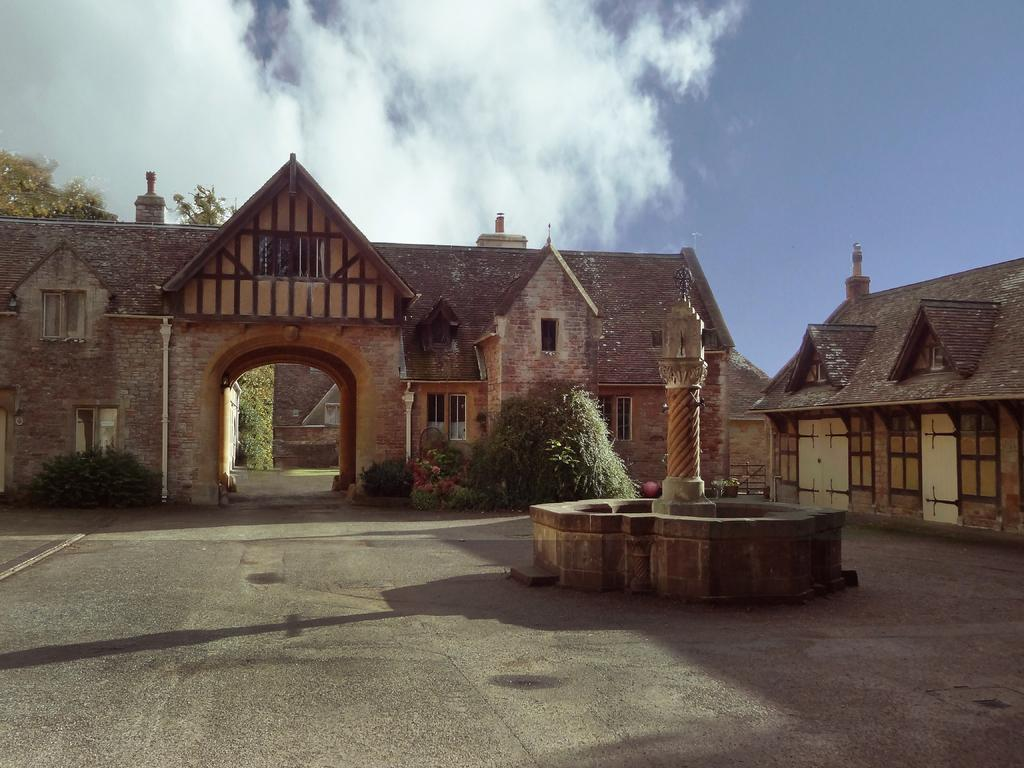What is the main structure in the center of the image? There is a pillar in the center of the image. What other architectural feature can be seen in the image? There is a wall in the image. What can be seen in the background of the image? There are houses, plants, and trees in the background of the image. How would you describe the sky in the image? The sky is cloudy in the image. Where can the lead be found in the image? There is no lead present in the image. What type of honey can be seen dripping from the trees in the image? There is no honey present in the image, and trees are not depicted as dripping anything. 